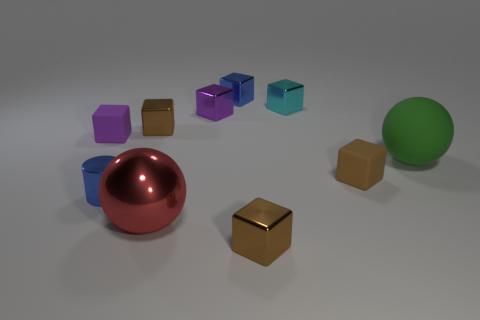There is a shiny cube that is in front of the red thing; is it the same color as the small cube that is to the left of the blue metal cylinder?
Keep it short and to the point. No. Is the number of small metallic objects behind the tiny blue cube greater than the number of brown objects?
Give a very brief answer. No. What is the cylinder made of?
Provide a short and direct response. Metal. There is a cyan thing that is made of the same material as the red object; what shape is it?
Your response must be concise. Cube. What size is the brown object that is left of the sphere in front of the big green ball?
Provide a succinct answer. Small. What color is the tiny rubber object that is to the right of the blue metallic cube?
Ensure brevity in your answer.  Brown. Is there another gray matte thing of the same shape as the big matte thing?
Provide a short and direct response. No. Is the number of red metal objects to the right of the cyan thing less than the number of metal blocks in front of the purple metal block?
Make the answer very short. Yes. What is the color of the small metal cylinder?
Your answer should be compact. Blue. Are there any large green matte objects in front of the tiny blue object in front of the small purple shiny object?
Keep it short and to the point. No. 